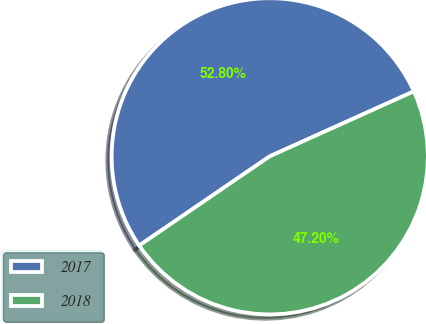Convert chart to OTSL. <chart><loc_0><loc_0><loc_500><loc_500><pie_chart><fcel>2017<fcel>2018<nl><fcel>52.8%<fcel>47.2%<nl></chart> 